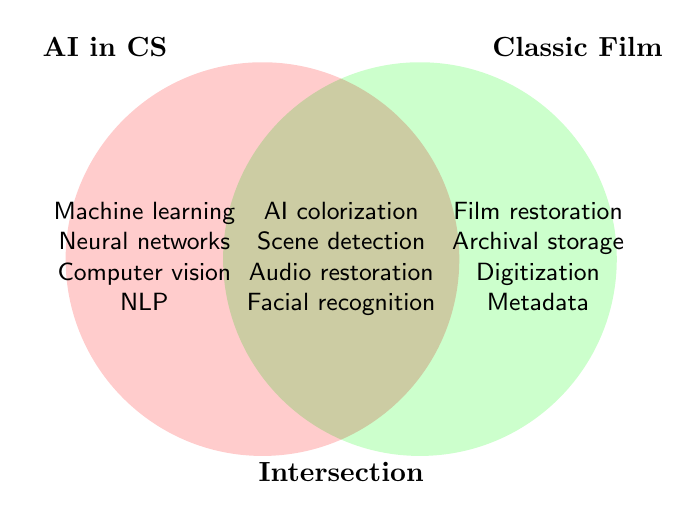What are the two main categories in the Venn diagram? The Venn diagram has two main categories, indicated by the titles above the circles. One circle is labeled "AI in CS" (Artificial Intelligence in Computer Science), and the other is labeled "Classic Film."
Answer: AI in CS and Classic Film Which techniques are found at the intersection of AI in Computer Science and Classic Film Preservation? The techniques in the intersection are listed in the overlapping area of the two circles. They include AI-powered colorization, automated scene detection, AI-enhanced audio restoration, and facial recognition for actor identification.
Answer: AI-powered colorization, automated scene detection, AI-enhanced audio restoration, and facial recognition How many techniques belong exclusively to the "AI in CS" category? The techniques exclusive to "AI in CS" are listed in the non-overlapping part of the left circle. There are four techniques: machine learning algorithms, neural networks, computer vision, and natural language processing.
Answer: Four List one technique that is only found in the "Classic Film" category and not in the intersection. By looking at the non-overlapping part of the "Classic Film" circle, one of the techniques listed is film restoration techniques.
Answer: Film restoration techniques What kind of data is used in the "Classic Film" category for archival purposes? Archival storage methods are mentioned in the "Classic Film" category. This implies that archival storage methods are used for keeping the data in a preserved manner.
Answer: Archival storage methods Compare the focus areas of AI in Computer Science and Classic Film Preservation. How do they differ? The focus areas for "AI in CS" include machine learning algorithms, neural networks, computer vision, and NLP, which are more technically oriented toward data processing and analysis. In contrast, "Classic Film Preservation" focuses on film restoration techniques, archival storage methods, analog film digitization, and metadata standards, emphasizing physical and historical preservation methods.
Answer: Technological focus vs. preservation focus Are there any techniques in "AI in CS" that can assist in audio aspects of classic film preservation? If so, which? Yes, in the intersection, "AI-enhanced audio restoration" is listed, which implies that this AI technique can assist in improving the audio aspects of classic film preservation.
Answer: AI-enhanced audio restoration What can be concluded about the use of facial recognition technology in the context of this diagram? Facial recognition technology is listed in the intersection, indicating that it is an AI application used for actor identification in classic films.
Answer: Actor identification Name one predictive technique used in AI in Computer Science, and discuss if it has an application in Classic Film Preservation. Predictive modeling is listed under "AI in CS" but does not explicitly appear in the intersection. However, predictive modeling could potentially be used in classic film preservation for predicting film deterioration or restoration outcomes, though this is not explicitly mentioned in the diagram.
Answer: Predictive modeling, potential use in predicting film deterioration Which specific AI technology can be used to identify actors in classic movies, according to the diagram? According to the diagram, facial recognition is the specific AI technology mentioned in the intersection that can be used for actor identification in classic movies.
Answer: Facial recognition 